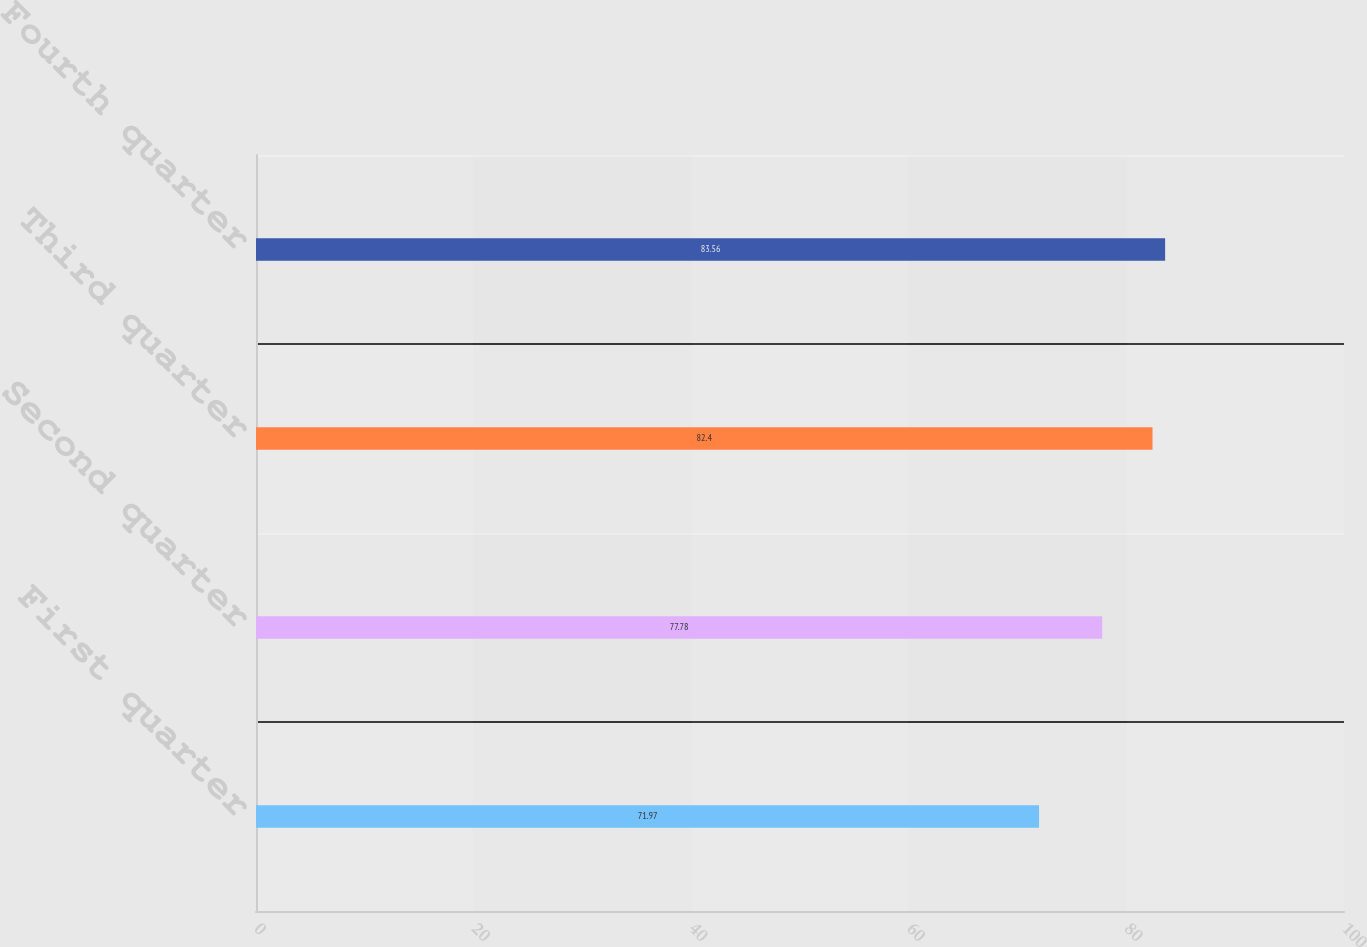Convert chart to OTSL. <chart><loc_0><loc_0><loc_500><loc_500><bar_chart><fcel>First quarter<fcel>Second quarter<fcel>Third quarter<fcel>Fourth quarter<nl><fcel>71.97<fcel>77.78<fcel>82.4<fcel>83.56<nl></chart> 